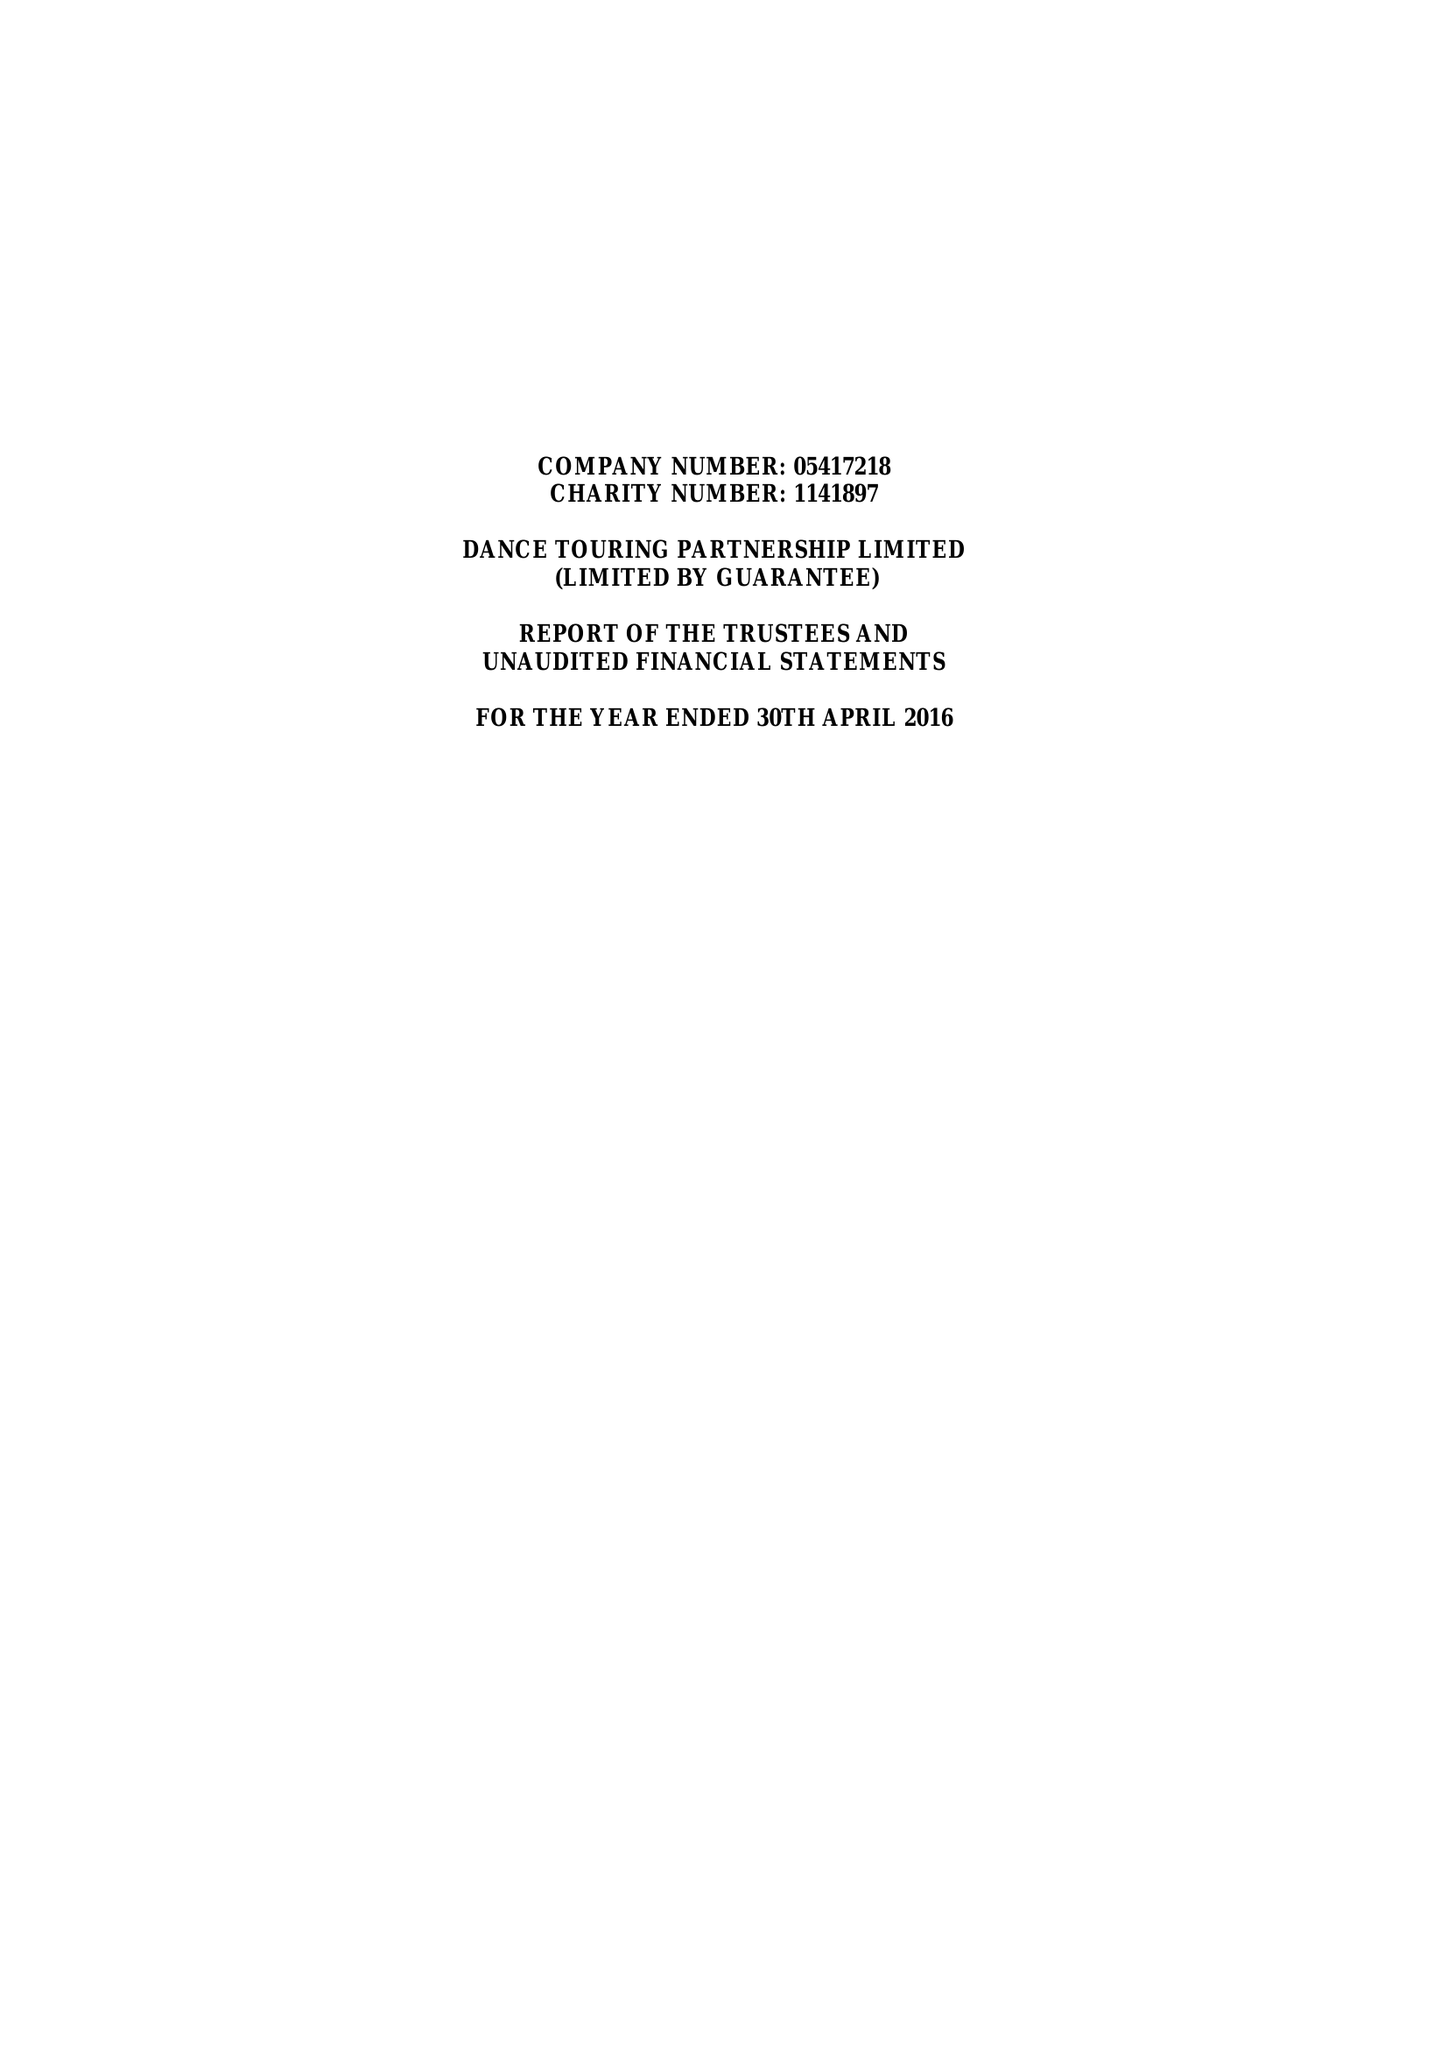What is the value for the charity_number?
Answer the question using a single word or phrase. 1141897 